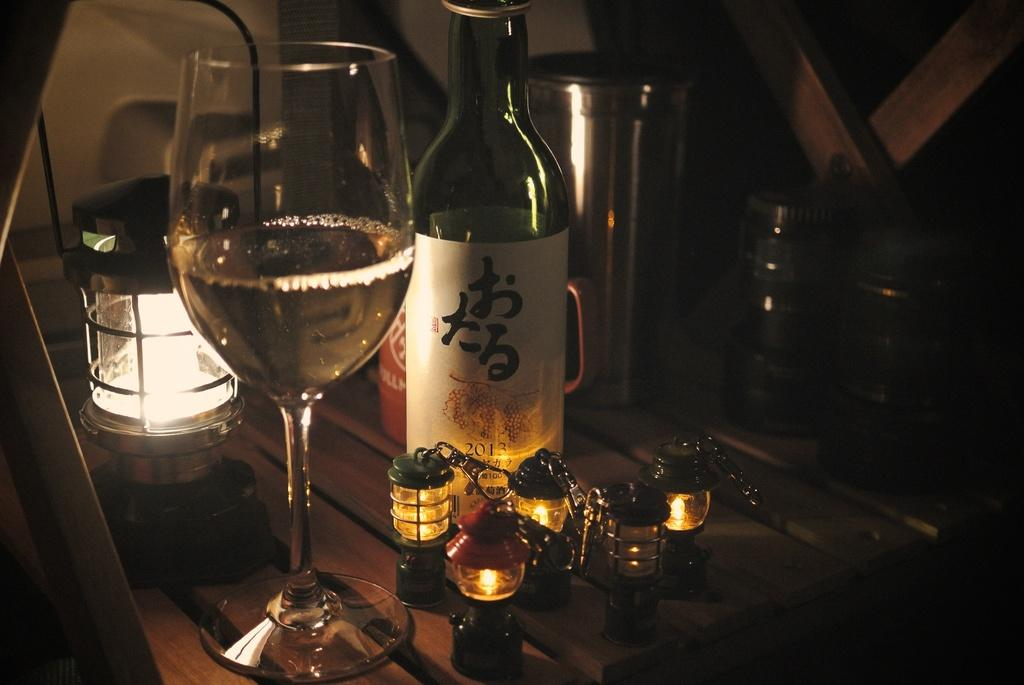What is in the wine glass that is visible in the image? There is a wine glass with wine in the image. What other items can be seen in the image? There is a glass bottle, jars, and tiny lamps visible in the image. What is the condition of the glass bottle in the image? The glass bottle has a cap in the image. What type of lighting is present in the image? There is a lamp and tiny lamps in the image. What is the surface that the objects are placed on in the image? The objects are placed on a wooden table in the image. What can be seen in the background of the image? There is a wooden wall in the background of the image. What type of parenting advice can be seen in the image? There is no parenting advice present in the image; it features a wine glass with wine, a glass bottle, jars, tiny lamps, and a wooden table and wall. 